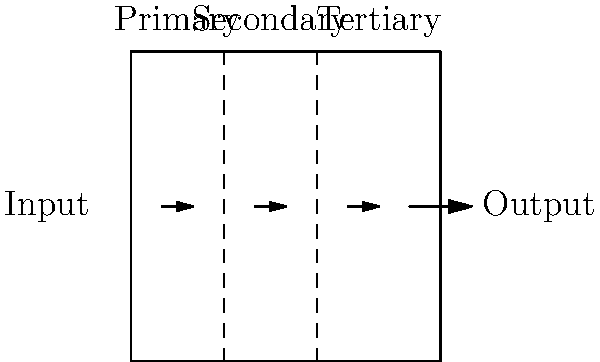As an eco-conscious craftsman, you're designing a wastewater treatment system for your workshop. The system uses three filtration stages: primary, secondary, and tertiary. If the primary stage removes 60% of contaminants, the secondary stage removes 80% of the remaining contaminants, and the tertiary stage removes 90% of what's left, what percentage of the original contaminants remains in the final treated water? Let's approach this step-by-step:

1. Start with 100% of contaminants.

2. After primary treatment:
   - 60% removed, so 40% remains
   - Remaining contaminants = 100% × (1 - 0.60) = 40%

3. After secondary treatment:
   - 80% of the remaining 40% is removed
   - Remaining contaminants = 40% × (1 - 0.80) = 8%

4. After tertiary treatment:
   - 90% of the remaining 8% is removed
   - Remaining contaminants = 8% × (1 - 0.90) = 0.8%

5. Calculate the final percentage:
   - 0.8% of the original contaminants remain

To verify:
$$100\% \times (1 - 0.60) \times (1 - 0.80) \times (1 - 0.90) = 0.8\%$$

This means that 99.2% of the original contaminants have been removed by the three-stage filtration system.
Answer: 0.8% of original contaminants remain 